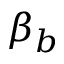Convert formula to latex. <formula><loc_0><loc_0><loc_500><loc_500>\beta _ { b }</formula> 